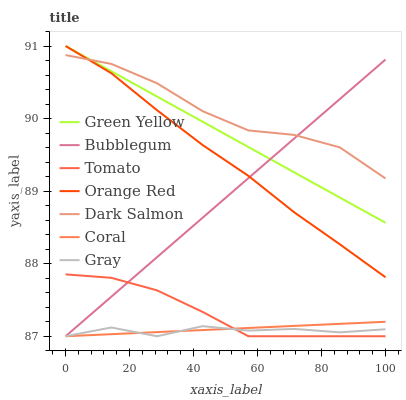Does Coral have the minimum area under the curve?
Answer yes or no. No. Does Coral have the maximum area under the curve?
Answer yes or no. No. Is Gray the smoothest?
Answer yes or no. No. Is Gray the roughest?
Answer yes or no. No. Does Dark Salmon have the lowest value?
Answer yes or no. No. Does Coral have the highest value?
Answer yes or no. No. Is Gray less than Orange Red?
Answer yes or no. Yes. Is Orange Red greater than Coral?
Answer yes or no. Yes. Does Gray intersect Orange Red?
Answer yes or no. No. 